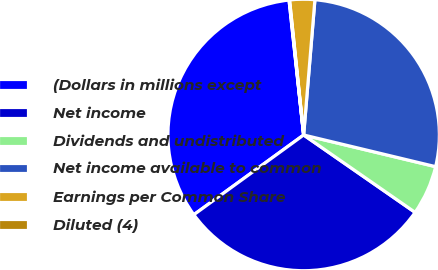Convert chart. <chart><loc_0><loc_0><loc_500><loc_500><pie_chart><fcel>(Dollars in millions except<fcel>Net income<fcel>Dividends and undistributed<fcel>Net income available to common<fcel>Earnings per Common Share<fcel>Diluted (4)<nl><fcel>33.28%<fcel>30.35%<fcel>5.91%<fcel>27.43%<fcel>2.98%<fcel>0.06%<nl></chart> 